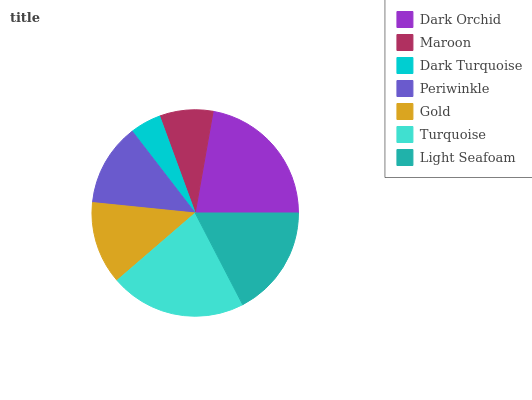Is Dark Turquoise the minimum?
Answer yes or no. Yes. Is Dark Orchid the maximum?
Answer yes or no. Yes. Is Maroon the minimum?
Answer yes or no. No. Is Maroon the maximum?
Answer yes or no. No. Is Dark Orchid greater than Maroon?
Answer yes or no. Yes. Is Maroon less than Dark Orchid?
Answer yes or no. Yes. Is Maroon greater than Dark Orchid?
Answer yes or no. No. Is Dark Orchid less than Maroon?
Answer yes or no. No. Is Periwinkle the high median?
Answer yes or no. Yes. Is Periwinkle the low median?
Answer yes or no. Yes. Is Gold the high median?
Answer yes or no. No. Is Light Seafoam the low median?
Answer yes or no. No. 